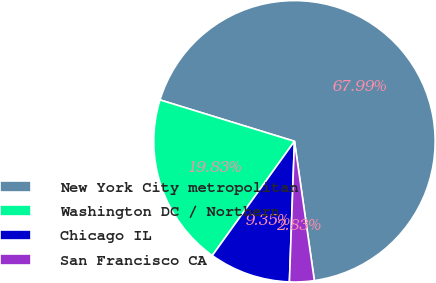Convert chart. <chart><loc_0><loc_0><loc_500><loc_500><pie_chart><fcel>New York City metropolitan<fcel>Washington DC / Northern<fcel>Chicago IL<fcel>San Francisco CA<nl><fcel>67.99%<fcel>19.83%<fcel>9.35%<fcel>2.83%<nl></chart> 